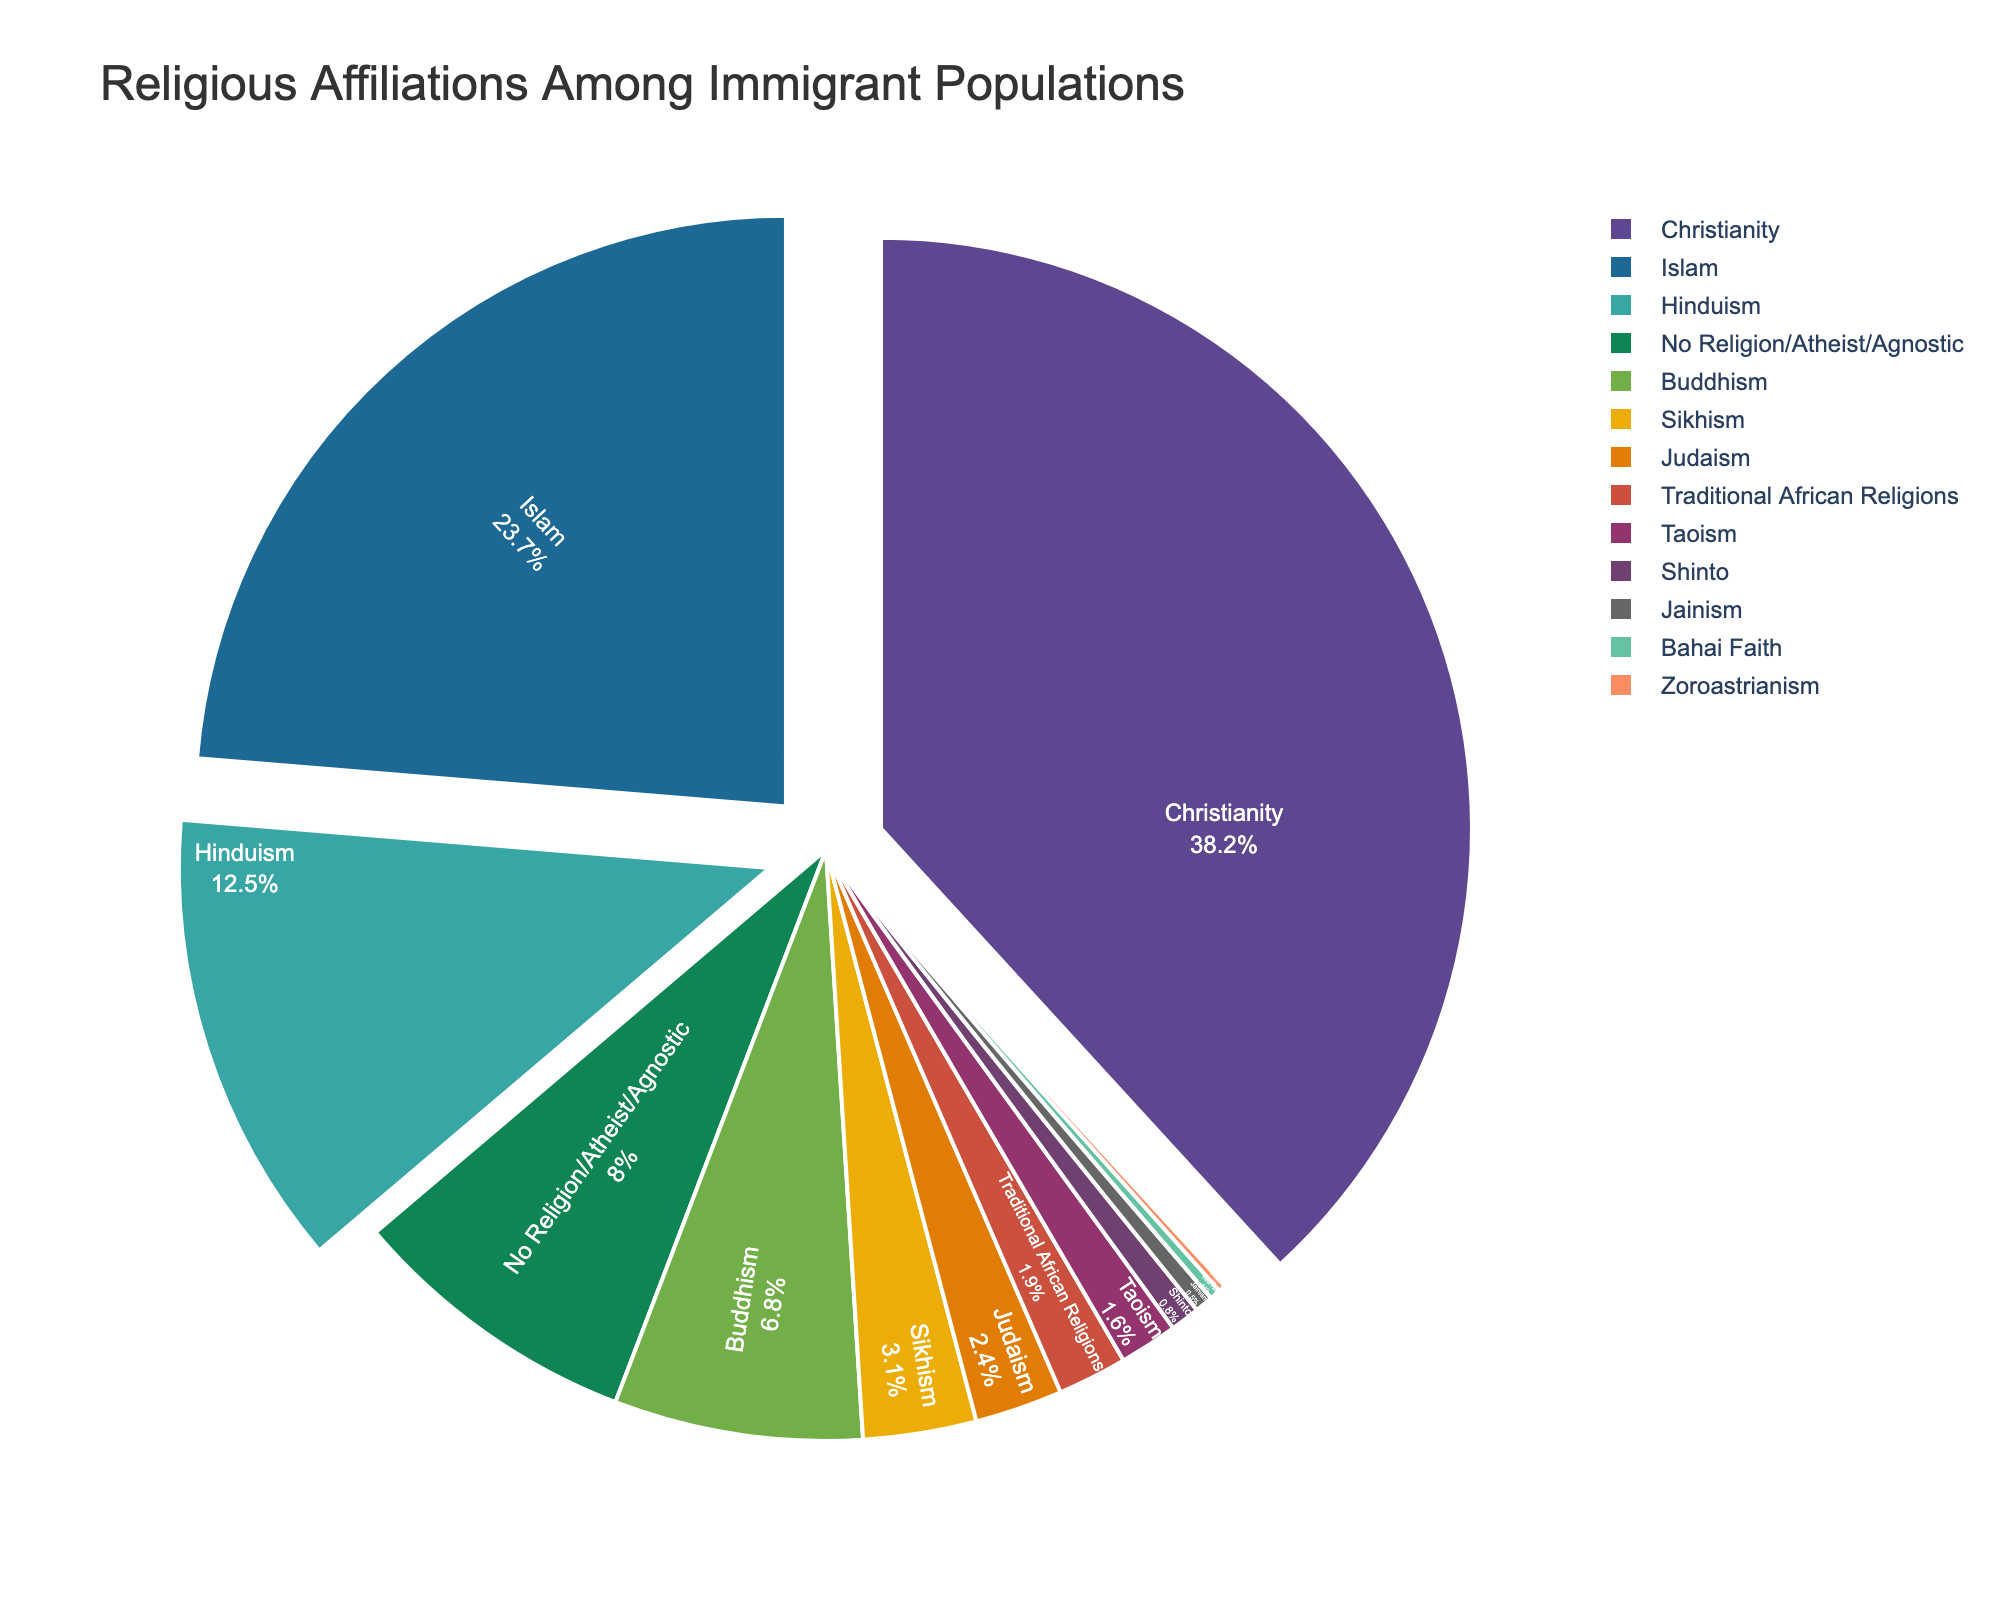What is the largest religious affiliation among the immigrant populations shown in the pie chart? The largest religious affiliation can be identified by finding the segment with the highest percentage. Christianity has the highest percentage among the given affiliations.
Answer: Christianity Which two religions have a combined percentage closest to 30%? To determine this, you add the percentages of different religion pairs and find the pair whose sum is closest to 30%. Hinduism (12.5%) and Islam (23.7%) sum to 36.2%, which is close, but Buddhism (6.8%) and Hinduism (12.5%) together give 19.3%. Therefore, Islam (23.7%) and Buddhism (6.8%) combined give 30.5%, which is closest.
Answer: Islam and Buddhism Which religion holds a higher percentage, Sikhism or Judaism? By comparing the percentages directly assigned to each religion in the dataset, Sikhism has 3.1% whereas Judaism has 2.4%.
Answer: Sikhism What is the total percentage of immigrants affiliated with religions that have less than 5% of the population each? Summing the percentages for religions with less than 5%: Sikhism (3.1%), Judaism (2.4%), Traditional African Religions (1.9%), Taoism (1.6%), Shinto (0.8%), Jainism (0.5%), Bahai Faith (0.3%), Zoroastrianism (0.2%). The total is: 3.1 + 2.4 + 1.9 + 1.6 + 0.8 + 0.5 + 0.3 + 0.2 = 10.8%.
Answer: 10.8% Which religious affiliations have more than 10% representation in the immigrant population? By inspecting the pie chart, Christianity (38.2%), Islam (23.7%), and Hinduism (12.5%) are the religions with representation greater than 10%.
Answer: Christianity, Islam, Hinduism Are there more immigrants with no religion/atheist/agnostic affiliations than those following Buddhism? Compare the percentages for No Religion/Atheist/Agnostic (8.0%) and Buddhism (6.8%). Since 8.0% is greater than 6.8%, there are more immigrants with no religion/atheist/agnostic affiliations.
Answer: Yes Which two religious affiliations combined have the smallest representation in the chart? Examine pairs with the smallest individual percentages: Bahai Faith (0.3%) and Zoroastrianism (0.2%). Together, they sum up to 0.5%. No smaller sum can be achieved by other pairs.
Answer: Bahai Faith and Zoroastrianism What percentage of the immigrant population adheres to Traditional African Religions and Taoism combined? Adding the percentages of Traditional African Religions (1.9%) and Taoism (1.6%) together gives: 1.9 + 1.6 = 3.5%.
Answer: 3.5% Which religion's segment slightly pulls out in the pie chart? Religions with segments slightly pulled out are those with percentages over 10%. These are Christianity, Islam, and Hinduism.
Answer: Christianity, Islam, Hinduism Which religious affiliation represents fewer than 1% but more than 0.5% of the immigrant population? The data indicates Shinto with 0.8% as the only affiliation fitting the criteria of being more than 0.5% but less than 1%.
Answer: Shinto 